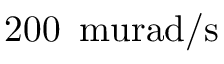Convert formula to latex. <formula><loc_0><loc_0><loc_500><loc_500>2 0 0 \, \ m u r a d / s</formula> 